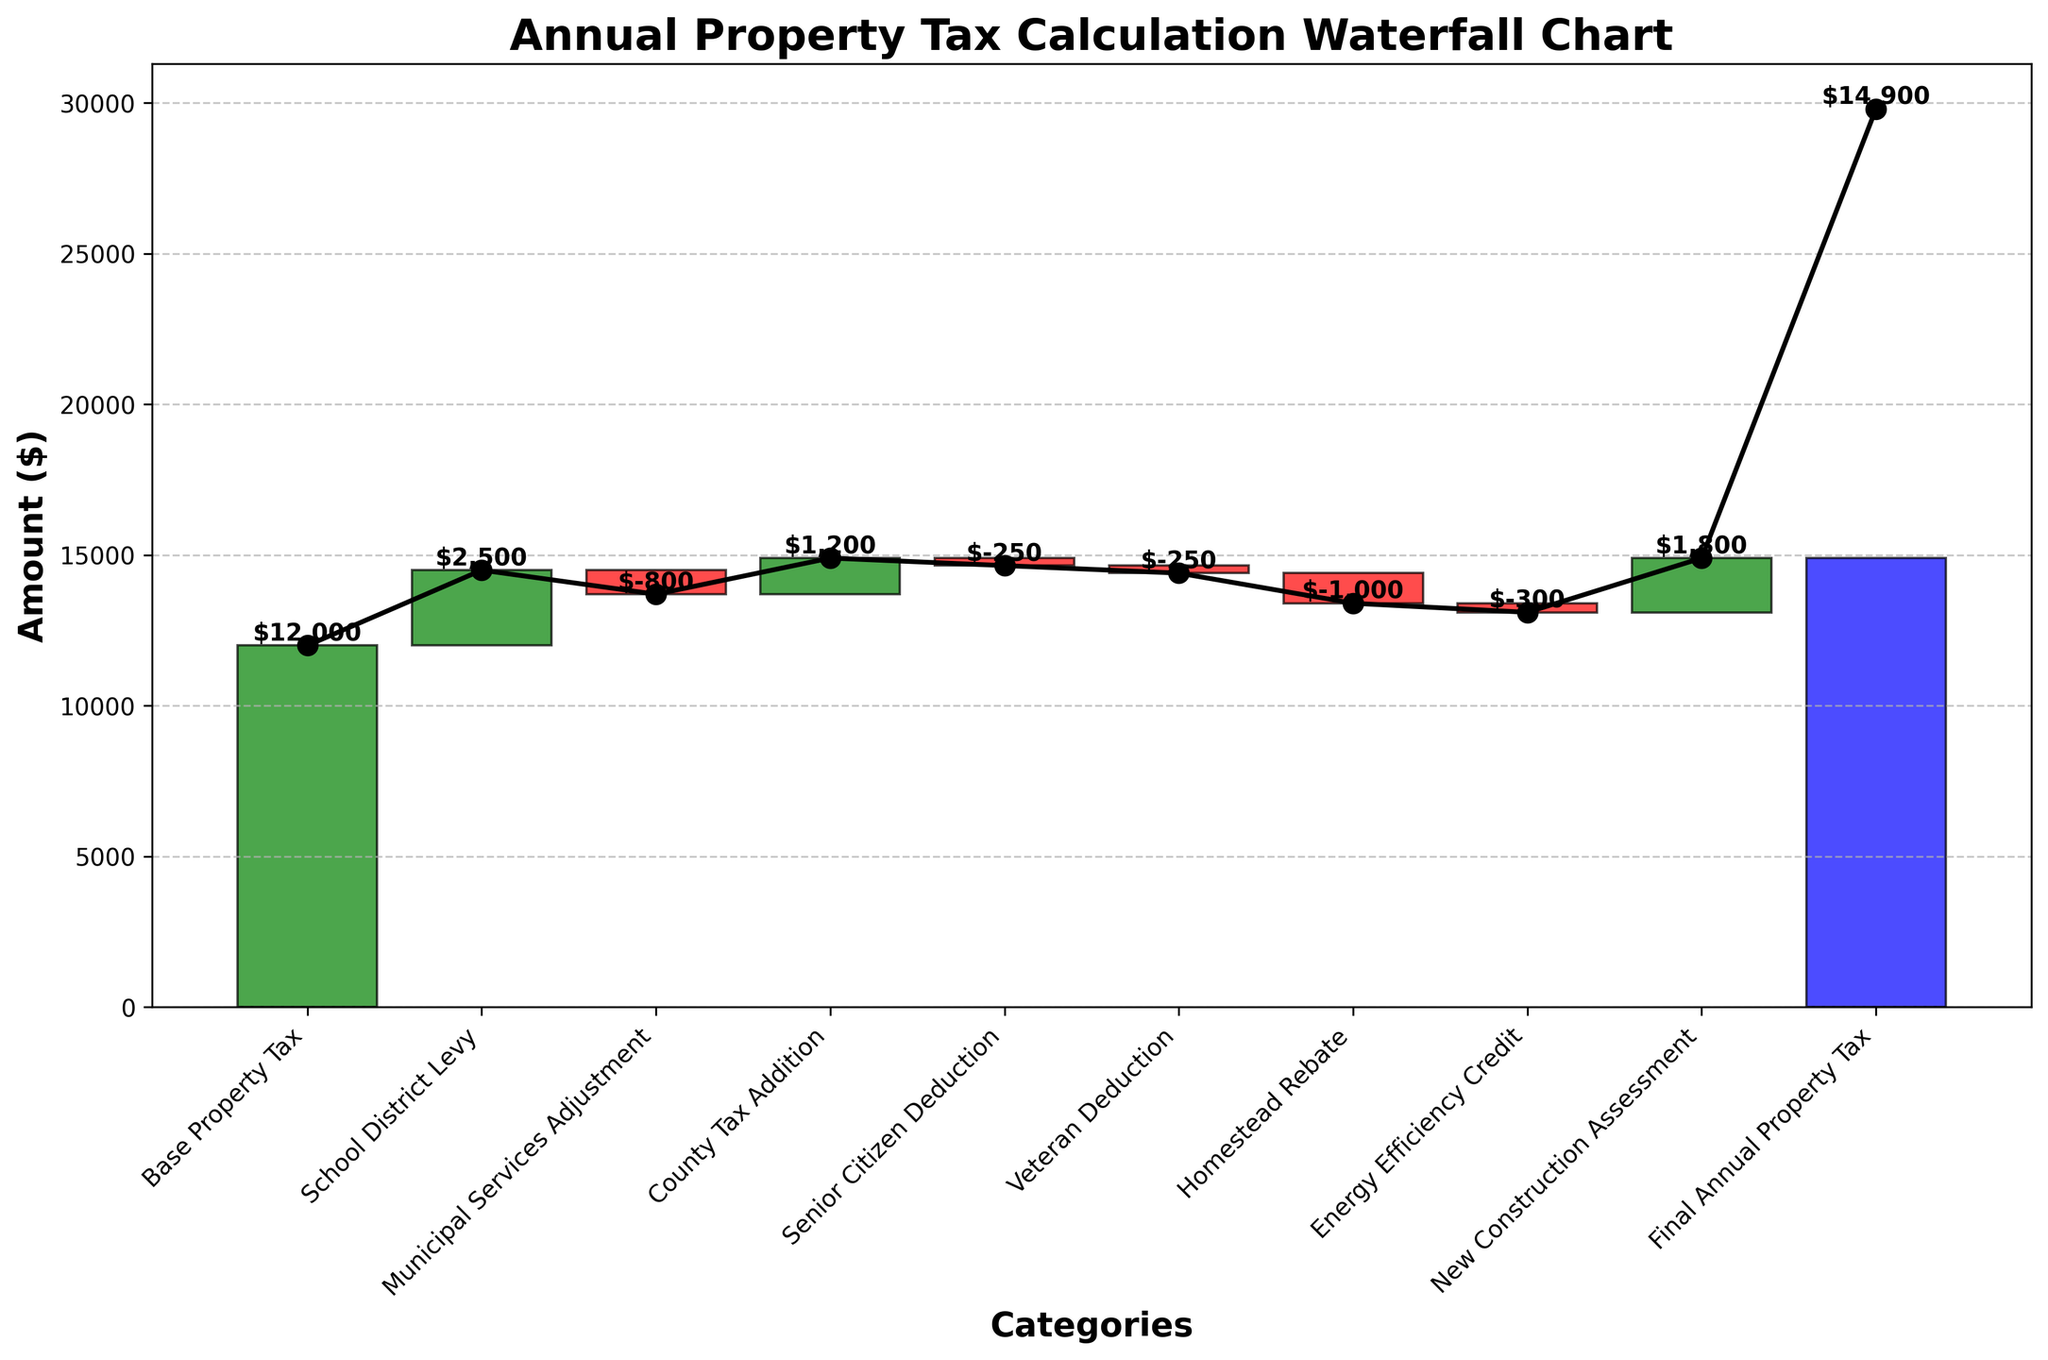What is the title of the chart? The title of the plot is typically found at the top and is usually larger or bolded compared to other text elements. In this case, it reads "Annual Property Tax Calculation Waterfall Chart".
Answer: Annual Property Tax Calculation Waterfall Chart How many categories are there on the x-axis? Count all the categories listed on the x-axis. They range from "Base Property Tax" to "Final Annual Property Tax". There are 10 categories.
Answer: 10 What is the value of the "Base Property Tax"? The "Base Property Tax" is the first bar in the chart. Its value is listed at the top of this bar. It shows $12,000.
Answer: $12,000 How much is deducted for the "Senior Citizen Deduction"? Locate the "Senior Citizen Deduction" bar, which is a negative adjustment. Its value is shown as -$250.
Answer: -$250 What is the total change due to deductions (negative adjustments)? Sum the values of all the negative adjustments: "Municipal Services Adjustment" (-800), "Senior Citizen Deduction" (-250), "Veteran Deduction" (-250), "Homestead Rebate" (-1000), and "Energy Efficiency Credit" (-300). The total is -$2600.
Answer: -$2600 Which category contributes the most to the increase in property tax? Compare the heights of all the positive adjustment bars. The "New Construction Assessment" has the highest value of $1800.
Answer: New Construction Assessment What is the final amount of the annual property tax? The final bar represents the "Final Annual Property Tax" and shows a value of $14,900.
Answer: $14,900 How much does the "School District Levy" add to the property tax? Locate the "School District Levy" bar, which is a positive adjustment. Its value is $2500.
Answer: $2500 What is the net change due to all adjustments to the base property tax? Calculate the sum of all adjustments. The total of the positive adjustments is $5500 (2500 + 1200 + 1800) and the total of the negative adjustments is -$2600. The net change is $5500 - $2600 = $2900.
Answer: $2900 By how much does the "Municipal Services Adjustment" reduce the property tax compared to the "Energy Efficiency Credit"? Subtract the value of the "Energy Efficiency Credit" (-300) from the "Municipal Services Adjustment" (-800). The reduction is -800 - (-300) = -800 + 300 = -500.
Answer: -$500 